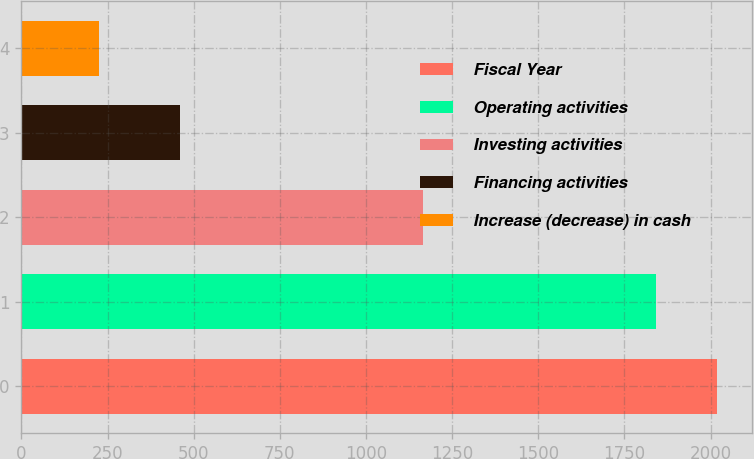<chart> <loc_0><loc_0><loc_500><loc_500><bar_chart><fcel>Fiscal Year<fcel>Operating activities<fcel>Investing activities<fcel>Financing activities<fcel>Increase (decrease) in cash<nl><fcel>2019<fcel>1841<fcel>1166<fcel>459<fcel>225<nl></chart> 